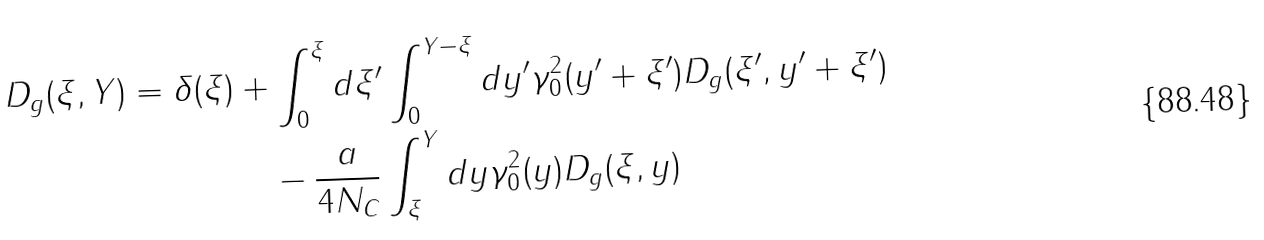Convert formula to latex. <formula><loc_0><loc_0><loc_500><loc_500>D _ { g } ( \xi , Y ) = \delta ( \xi ) & + \int _ { 0 } ^ { \xi } d \xi ^ { \prime } \int _ { 0 } ^ { Y - \xi } d y ^ { \prime } \gamma _ { 0 } ^ { 2 } ( y ^ { \prime } + \xi ^ { \prime } ) D _ { g } ( \xi ^ { \prime } , y ^ { \prime } + \xi ^ { \prime } ) \\ \quad & \quad - \frac { a } { 4 N _ { C } } \int _ { \xi } ^ { Y } d y \gamma _ { 0 } ^ { 2 } ( y ) D _ { g } ( \xi , y )</formula> 